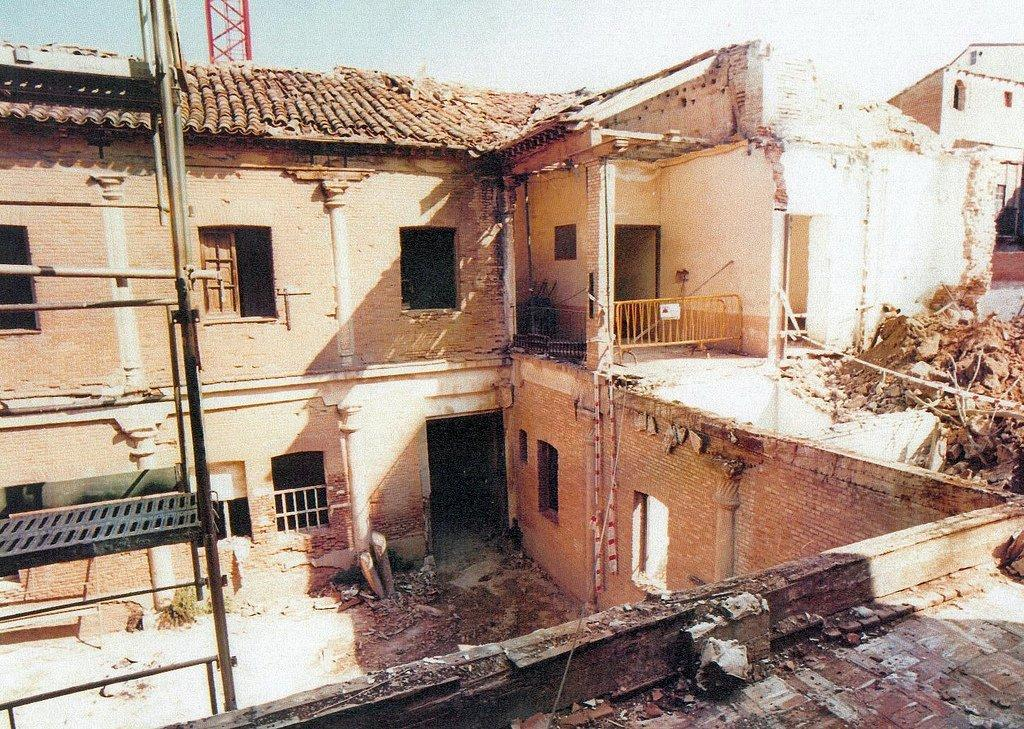What is the main subject of the image? The main subject of the image is a partially demolished building. What can be seen near the building in the image? There is a barricade in the image. What architectural features are visible on the building? There are windows in the building. Is there any equipment visible in the image? Yes, there appears to be a ladder in the image. What type of animal can be seen attending the meeting in the image? There is no meeting or animal present in the image; it depicts a partially demolished building with a barricade, windows, and a ladder. 